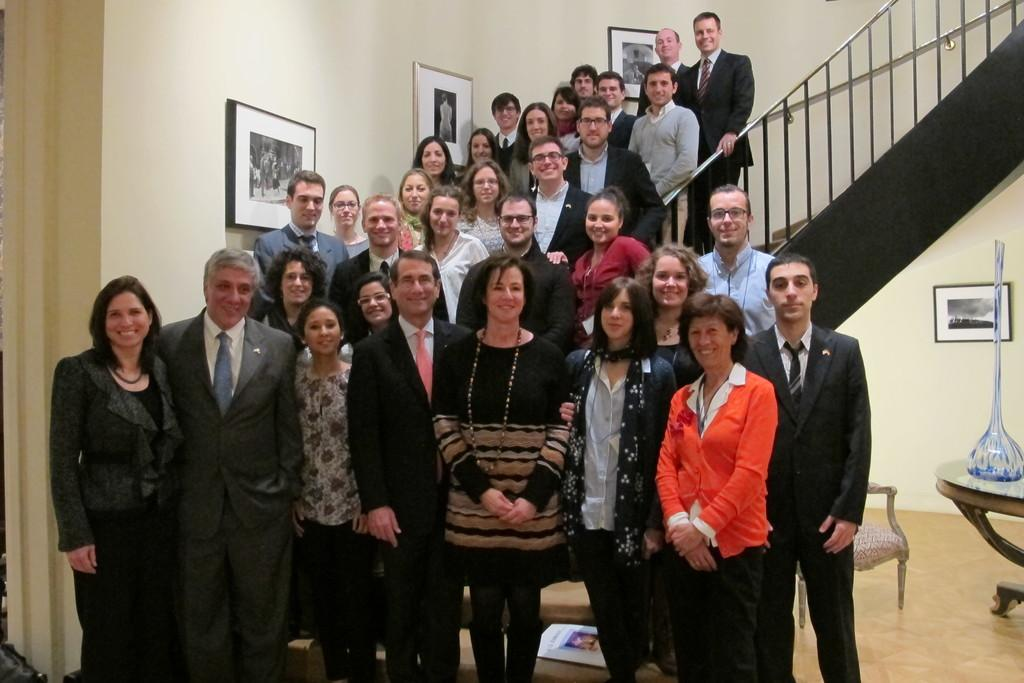What can be seen in the image involving people? There are people standing in the image. What type of architectural feature is present in the image? There is railing and steps in the image. What is hanging on the wall in the image? There are frames on the wall in the image. What is on a table in the image? There is a glass object on a table in the image. What type of furniture is in the image? There is a chair in the image. What type of signage is present in the image? There is a poster in the image. What type of health advice is given on the poster in the image? There is no health advice present on the poster in the image; it is a poster with an unspecified message or image. What type of room is depicted in the image? The image does not depict a room; it is a scene with people, railing, steps, frames, a glass object, and a chair. 